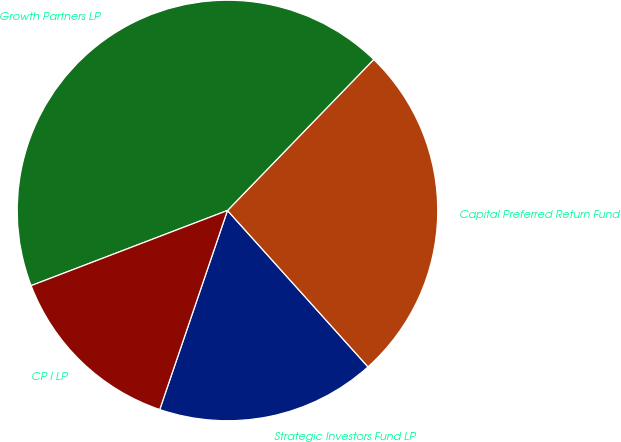<chart> <loc_0><loc_0><loc_500><loc_500><pie_chart><fcel>Strategic Investors Fund LP<fcel>Capital Preferred Return Fund<fcel>Growth Partners LP<fcel>CP I LP<nl><fcel>16.87%<fcel>26.1%<fcel>43.06%<fcel>13.96%<nl></chart> 